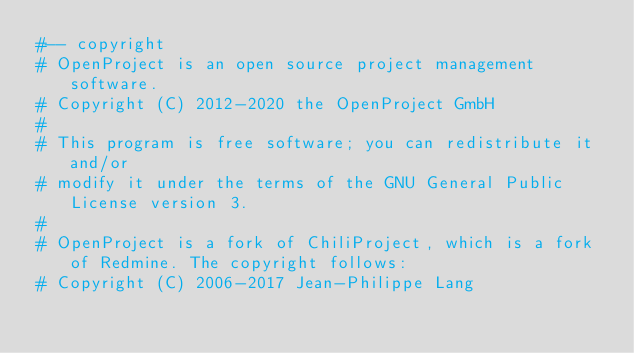<code> <loc_0><loc_0><loc_500><loc_500><_Ruby_>#-- copyright
# OpenProject is an open source project management software.
# Copyright (C) 2012-2020 the OpenProject GmbH
#
# This program is free software; you can redistribute it and/or
# modify it under the terms of the GNU General Public License version 3.
#
# OpenProject is a fork of ChiliProject, which is a fork of Redmine. The copyright follows:
# Copyright (C) 2006-2017 Jean-Philippe Lang</code> 